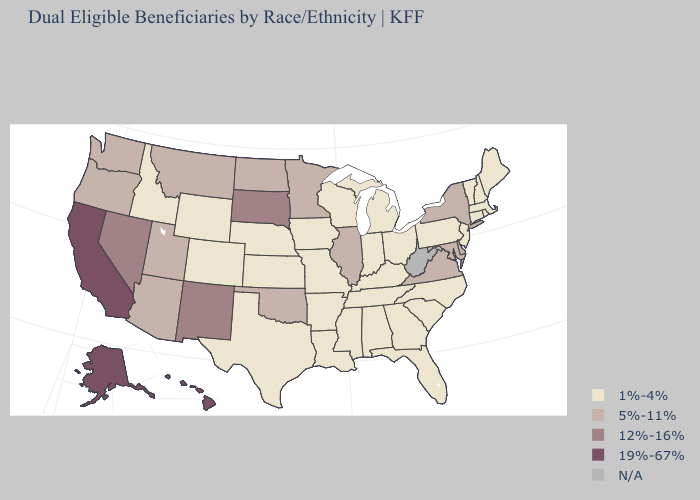What is the value of Massachusetts?
Keep it brief. 1%-4%. What is the highest value in the South ?
Concise answer only. 5%-11%. What is the value of Missouri?
Write a very short answer. 1%-4%. Among the states that border Virginia , which have the lowest value?
Quick response, please. Kentucky, North Carolina, Tennessee. Name the states that have a value in the range 5%-11%?
Concise answer only. Arizona, Delaware, Illinois, Maryland, Minnesota, Montana, New York, North Dakota, Oklahoma, Oregon, Utah, Virginia, Washington. How many symbols are there in the legend?
Give a very brief answer. 5. Name the states that have a value in the range 5%-11%?
Be succinct. Arizona, Delaware, Illinois, Maryland, Minnesota, Montana, New York, North Dakota, Oklahoma, Oregon, Utah, Virginia, Washington. How many symbols are there in the legend?
Be succinct. 5. Does Colorado have the lowest value in the West?
Answer briefly. Yes. How many symbols are there in the legend?
Keep it brief. 5. Name the states that have a value in the range 19%-67%?
Quick response, please. Alaska, California, Hawaii. What is the value of Hawaii?
Answer briefly. 19%-67%. Which states have the highest value in the USA?
Keep it brief. Alaska, California, Hawaii. 